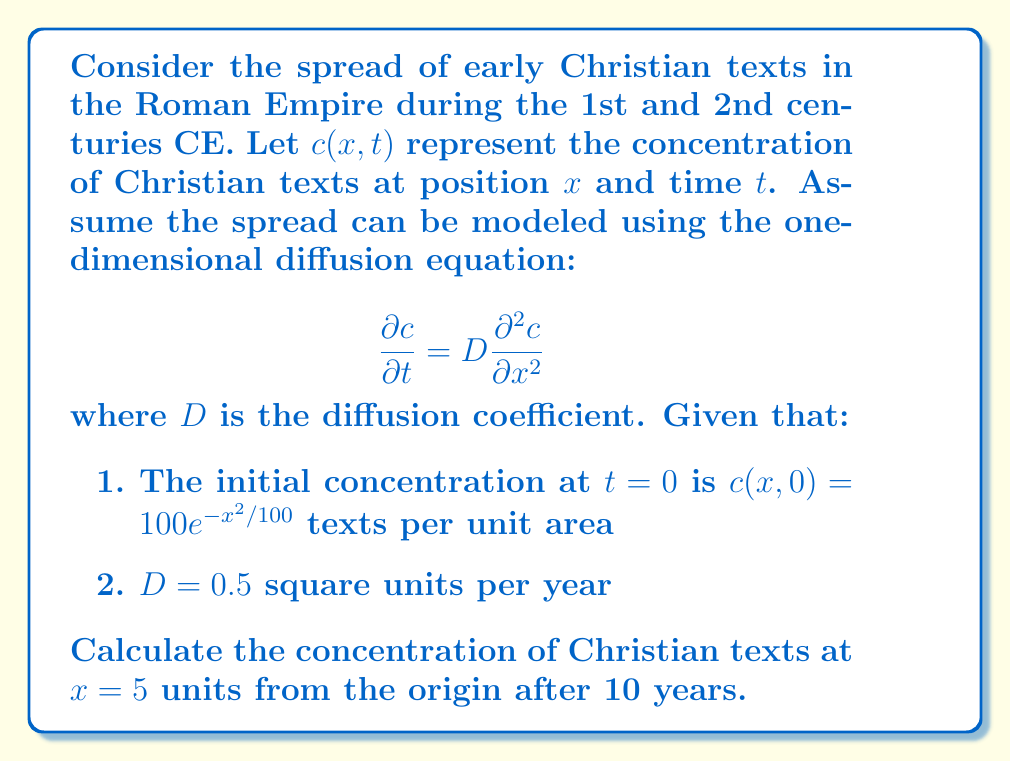What is the answer to this math problem? To solve this problem, we need to use the solution to the diffusion equation for an initial Gaussian distribution. The solution is:

$$c(x,t) = \frac{M}{\sqrt{4\pi Dt + \sigma^2}} \exp\left(-\frac{x^2}{4Dt + \sigma^2}\right)$$

where $M$ is the total number of texts and $\sigma^2$ is the initial variance of the Gaussian distribution.

Step 1: Identify the initial distribution parameters
The initial distribution is $c(x,0) = 100e^{-x^2/100}$, so $\sigma^2 = 50$ and $M = 100\sqrt{50\pi}$.

Step 2: Substitute the known values
$D = 0.5$, $t = 10$, $x = 5$

Step 3: Calculate the concentration
$$\begin{aligned}
c(5,10) &= \frac{100\sqrt{50\pi}}{\sqrt{4\pi(0.5)(10) + 50}} \exp\left(-\frac{5^2}{4(0.5)(10) + 50}\right) \\
&= \frac{100\sqrt{50\pi}}{\sqrt{20\pi + 50}} \exp\left(-\frac{25}{20 + 50}\right) \\
&= \frac{100\sqrt{50\pi}}{\sqrt{70\pi}} \exp\left(-\frac{25}{70}\right) \\
&\approx 59.76
\end{aligned}$$
Answer: 59.76 texts per unit area 